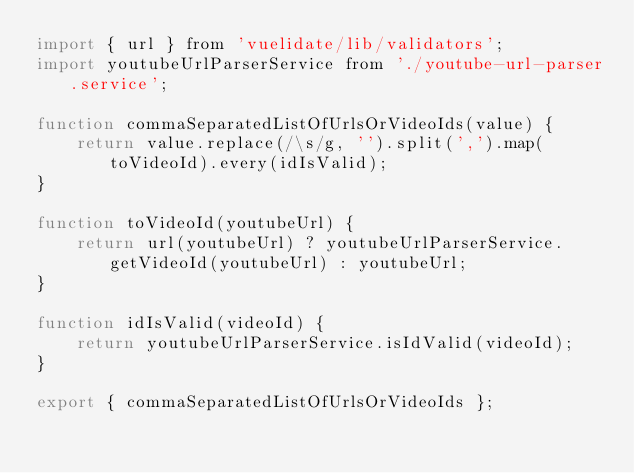Convert code to text. <code><loc_0><loc_0><loc_500><loc_500><_JavaScript_>import { url } from 'vuelidate/lib/validators';
import youtubeUrlParserService from './youtube-url-parser.service';

function commaSeparatedListOfUrlsOrVideoIds(value) {
    return value.replace(/\s/g, '').split(',').map(toVideoId).every(idIsValid);
}

function toVideoId(youtubeUrl) {
    return url(youtubeUrl) ? youtubeUrlParserService.getVideoId(youtubeUrl) : youtubeUrl;
}

function idIsValid(videoId) {
    return youtubeUrlParserService.isIdValid(videoId);
}

export { commaSeparatedListOfUrlsOrVideoIds };
</code> 